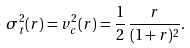Convert formula to latex. <formula><loc_0><loc_0><loc_500><loc_500>\sigma _ { t } ^ { 2 } ( r ) = v _ { c } ^ { 2 } ( r ) = \frac { 1 } { 2 } \, \frac { r } { ( 1 + r ) ^ { 2 } } .</formula> 